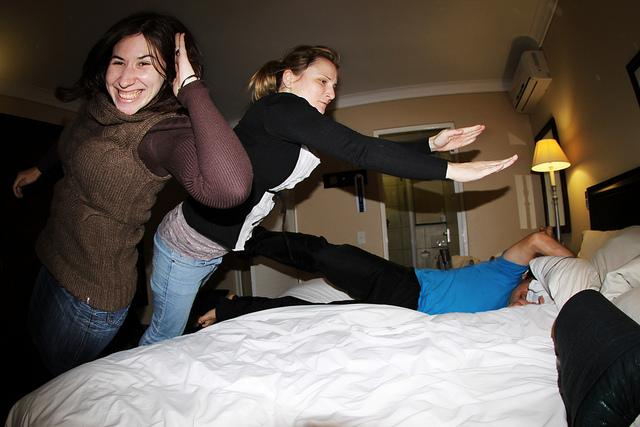Where are these people? Please explain your reasoning. hotel room. The room is in a hotel. 